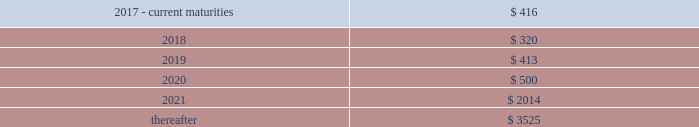F-772016 annual report the hartford financial services group , inc .
Notes to consolidated financial statements ( continued ) 13 .
Debt ( continued ) the 7.875% ( 7.875 % ) and 8.125% ( 8.125 % ) debentures may be redeemed in whole prior to the call date upon certain tax or rating agency events , at a price equal to the greater of 100% ( 100 % ) of the principal amount being redeemed and the applicable make-whole amount plus any accrued and unpaid interest .
The company may elect to redeem the 8.125% ( 8.125 % ) debentures in whole or part at its option prior to the call date at a price equal to the greater of 100% ( 100 % ) of the principal amount being redeemed and the applicable make-whole amount plus any accrued and unpaid interest .
The company may elect to redeem the 7.875% ( 7.875 % ) and 8.125% ( 8.125 % ) debentures in whole or in part on or after the call date for the principal amount being redeemed plus accrued and unpaid interest to the date of redemption .
In connection with the offering of the 8.125% ( 8.125 % ) debentures , the company entered into a replacement capital covenant ( 201crcc 201d ) for the benefit of holders of one or more designated series of the company 2019s indebtedness , initially the company 2019s 6.1% ( 6.1 % ) notes due 2041 .
Under the terms of the rcc , if the company redeems the 8.125% ( 8.125 % ) debentures at any time prior to june 15 , 2048 it can only do so with the proceeds from the sale of certain qualifying replacement securities .
On february 7 , 2017 , the company executed an amendment to the rcc to lengthen the amount of time the company has to issue qualifying replacement securities prior to the redemption of the 8.125% ( 8.125 % ) debentures and to amend the definition of certain qualifying replacement securities .
Long-term debt long-term debt maturities ( at par value ) as of december 31 , 2016 .
Shelf registrations on july 29 , 2016 , the company filed with the securities and exchange commission ( the 201csec 201d ) an automatic shelf registration statement ( registration no .
333-212778 ) for the potential offering and sale of debt and equity securities .
The registration statement allows for the following types of securities to be offered : debt securities , junior subordinated debt securities , preferred stock , common stock , depositary shares , warrants , stock purchase contracts , and stock purchase units .
In that the hartford is a well- known seasoned issuer , as defined in rule 405 under the securities act of 1933 , the registration statement went effective immediately upon filing and the hartford may offer and sell an unlimited amount of securities under the registration statement during the three-year life of the registration statement .
Contingent capital facility the hartford is party to a put option agreement that provides the hartford with the right to require the glen meadow abc trust , a delaware statutory trust , at any time and from time to time , to purchase the hartford 2019s junior subordinated notes in a maximum aggregate principal amount not to exceed $ 500 .
On february 8 , 2017 , the hartford exercised the put option resulting in the issuance of $ 500 in junior subordinated notes with proceeds received on february 15 , 2017 .
Under the put option agreement , the hartford had been paying the glen meadow abc trust premiums on a periodic basis , calculated with respect to the aggregate principal amount of notes that the hartford had the right to put to the glen meadow abc trust for such period .
The hartford has agreed to reimburse the glen meadow abc trust for certain fees and ordinary expenses .
The company holds a variable interest in the glen meadow abc trust where the company is not the primary beneficiary .
As a result , the company does not consolidate the glen meadow abc trust .
The junior subordinated notes have a scheduled maturity of february 12 , 2047 , and a final maturity of february 12 , 2067 .
The company is required to use reasonable efforts to sell certain qualifying replacement securities in order to repay the debentures at the scheduled maturity date .
The junior subordinated notes bear interest at an annual rate of three-month libor plus 2.125% ( 2.125 % ) , payable quarterly , and are unsecured , subordinated indebtedness of the hartford .
The hartford will have the right , on one or more occasions , to defer interest payments due on the junior subordinated notes under specified circumstances .
Upon receipt of the proceeds , the company entered into a replacement capital covenant ( the 201crcc 201d ) for the benefit of holders of one or more designated series of the company 2019s indebtedness , initially the company 2019s 4.3% ( 4.3 % ) notes due 2043 .
Under the terms of the rcc , if the company redeems the debentures at any time prior to february 12 , 2047 ( or such earlier date on which the rcc terminates by its terms ) it can only do so with the proceeds from the sale of certain qualifying replacement securities .
The rcc also prohibits the company from redeeming all or any portion of the notes on or prior to february 15 , 2022 .
Revolving credit facilities the company has a senior unsecured five-year revolving credit facility ( the 201ccredit facility 201d ) that provides for borrowing capacity up to $ 1 billion of unsecured credit through october 31 , 2019 available in u.s .
Dollars , euro , sterling , canadian dollars and japanese yen .
As of december 31 , 2016 , no borrowings were outstanding under the credit facility .
As of december 31 , 2016 , the company was in compliance with all financial covenants within the credit facility .
Commercial paper the hartford 2019s maximum borrowings available under its commercial paper program are $ 1 billion .
The company is dependent upon market conditions to access short-term financing through the issuance of commercial paper to investors .
As of december 31 , 2016 , there was no commercial paper outstanding. .
What is the total long-term debt reported in the balance sheet as of december 31 , 2016? 
Computations: ((((416 + 320) + 413) + 500) + 3525)
Answer: 5174.0. 